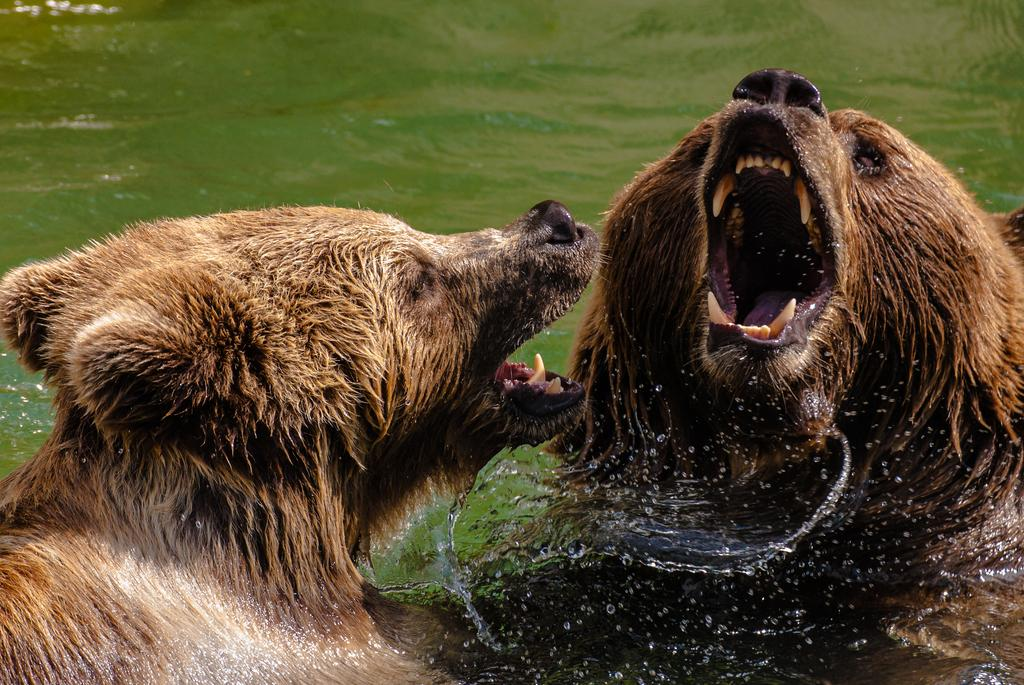How many animals are present in the image? There are two animals in the image. What can be seen in the background or surrounding the animals? Water is visible in the image. What type of suit is the water wearing in the image? There is no suit present in the image, as water is a liquid and does not wear clothing. 